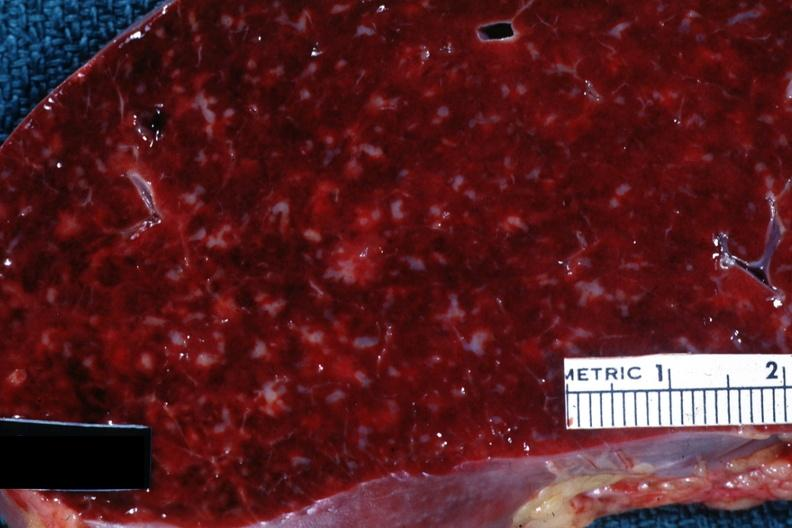s acrocyanosis present?
Answer the question using a single word or phrase. No 